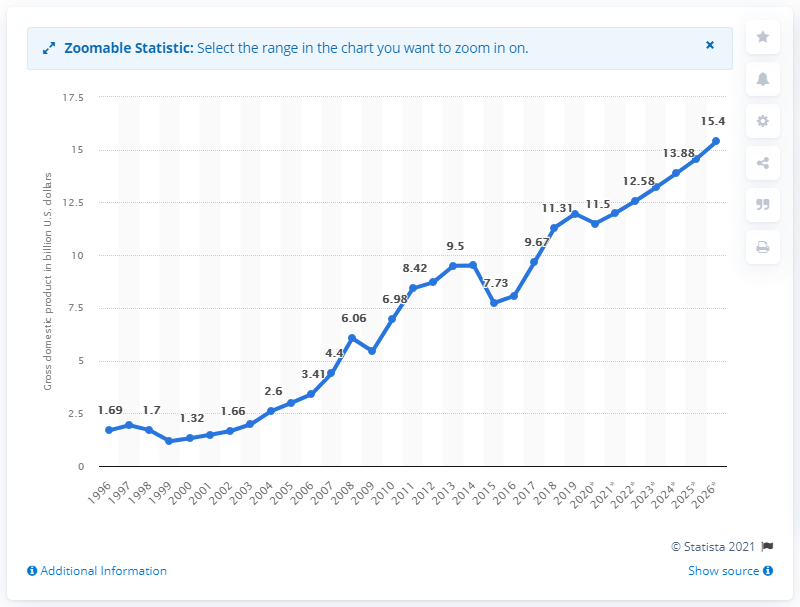List a handful of essential elements in this visual. In 2019, Moldova's gross domestic product was 12... 